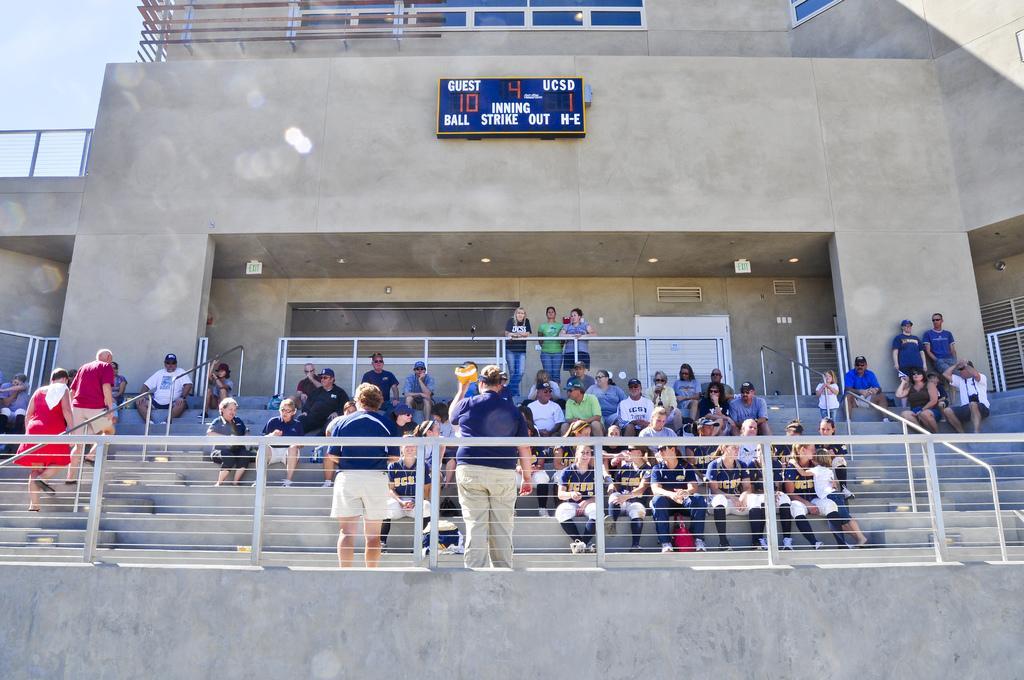In one or two sentences, can you explain what this image depicts? In this picture there are group of people sitting and there are group of people standing and there are two persons walking and there is a stair case and there are hand rails and there is a railing. At the back there is a building and there is a door and there is a board on the wall and there is text on the board and there are lights. At the top there is sky. 